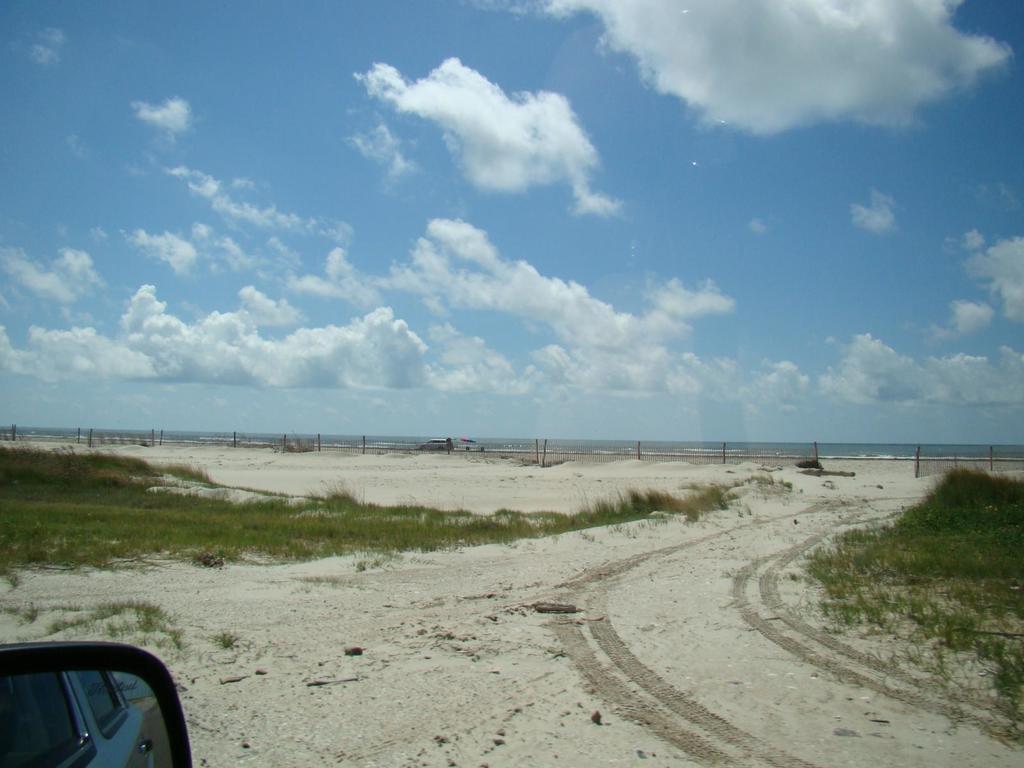Could you give a brief overview of what you see in this image? This image is taken outdoors. At the top of the image there is the sky with clouds. At the bottom of the image there is a ground. At the left bottom of the image there is a side mirror of a vehicle. In the middle of the image there is grass on the ground. 